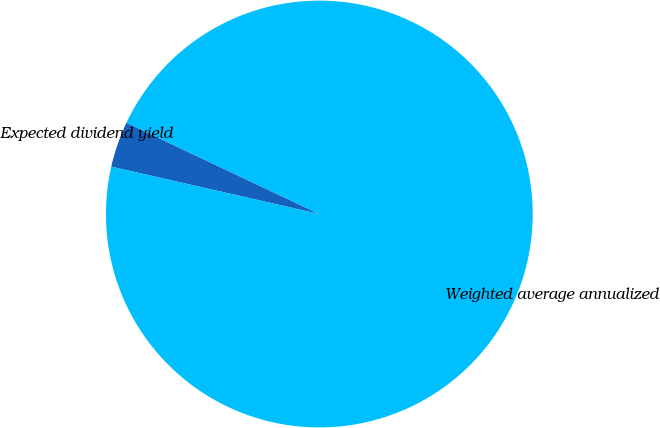Convert chart to OTSL. <chart><loc_0><loc_0><loc_500><loc_500><pie_chart><fcel>Expected dividend yield<fcel>Weighted average annualized<nl><fcel>3.47%<fcel>96.53%<nl></chart> 